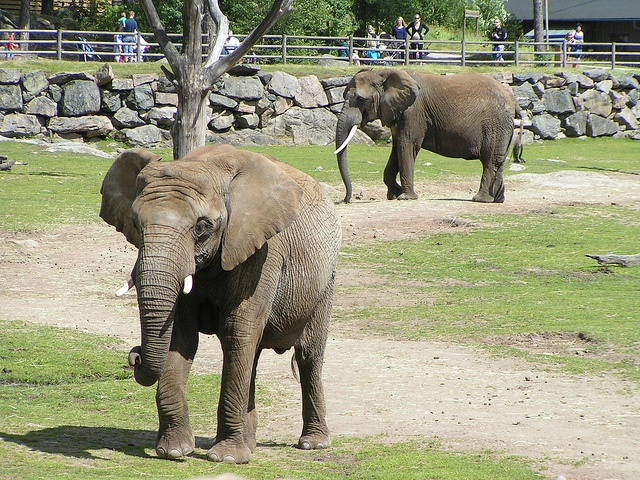Describe the objects in this image and their specific colors. I can see elephant in black, tan, and gray tones, elephant in black, gray, tan, and darkgray tones, people in black, ivory, gray, and navy tones, people in black, gray, white, and navy tones, and people in black, gray, beige, navy, and darkgray tones in this image. 